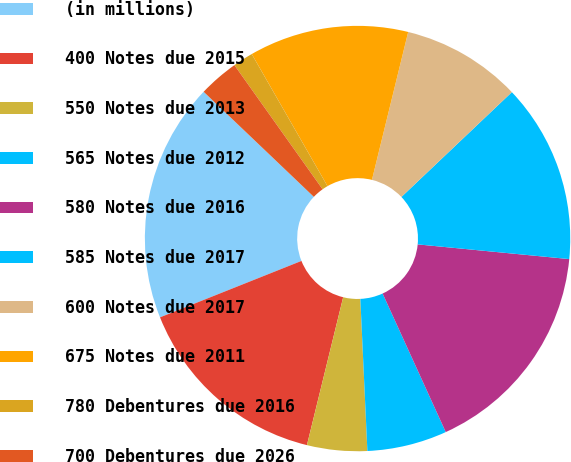Convert chart to OTSL. <chart><loc_0><loc_0><loc_500><loc_500><pie_chart><fcel>(in millions)<fcel>400 Notes due 2015<fcel>550 Notes due 2013<fcel>565 Notes due 2012<fcel>580 Notes due 2016<fcel>585 Notes due 2017<fcel>600 Notes due 2017<fcel>675 Notes due 2011<fcel>780 Debentures due 2016<fcel>700 Debentures due 2026<nl><fcel>18.16%<fcel>15.13%<fcel>4.56%<fcel>6.07%<fcel>16.65%<fcel>13.62%<fcel>9.09%<fcel>12.11%<fcel>1.54%<fcel>3.05%<nl></chart> 